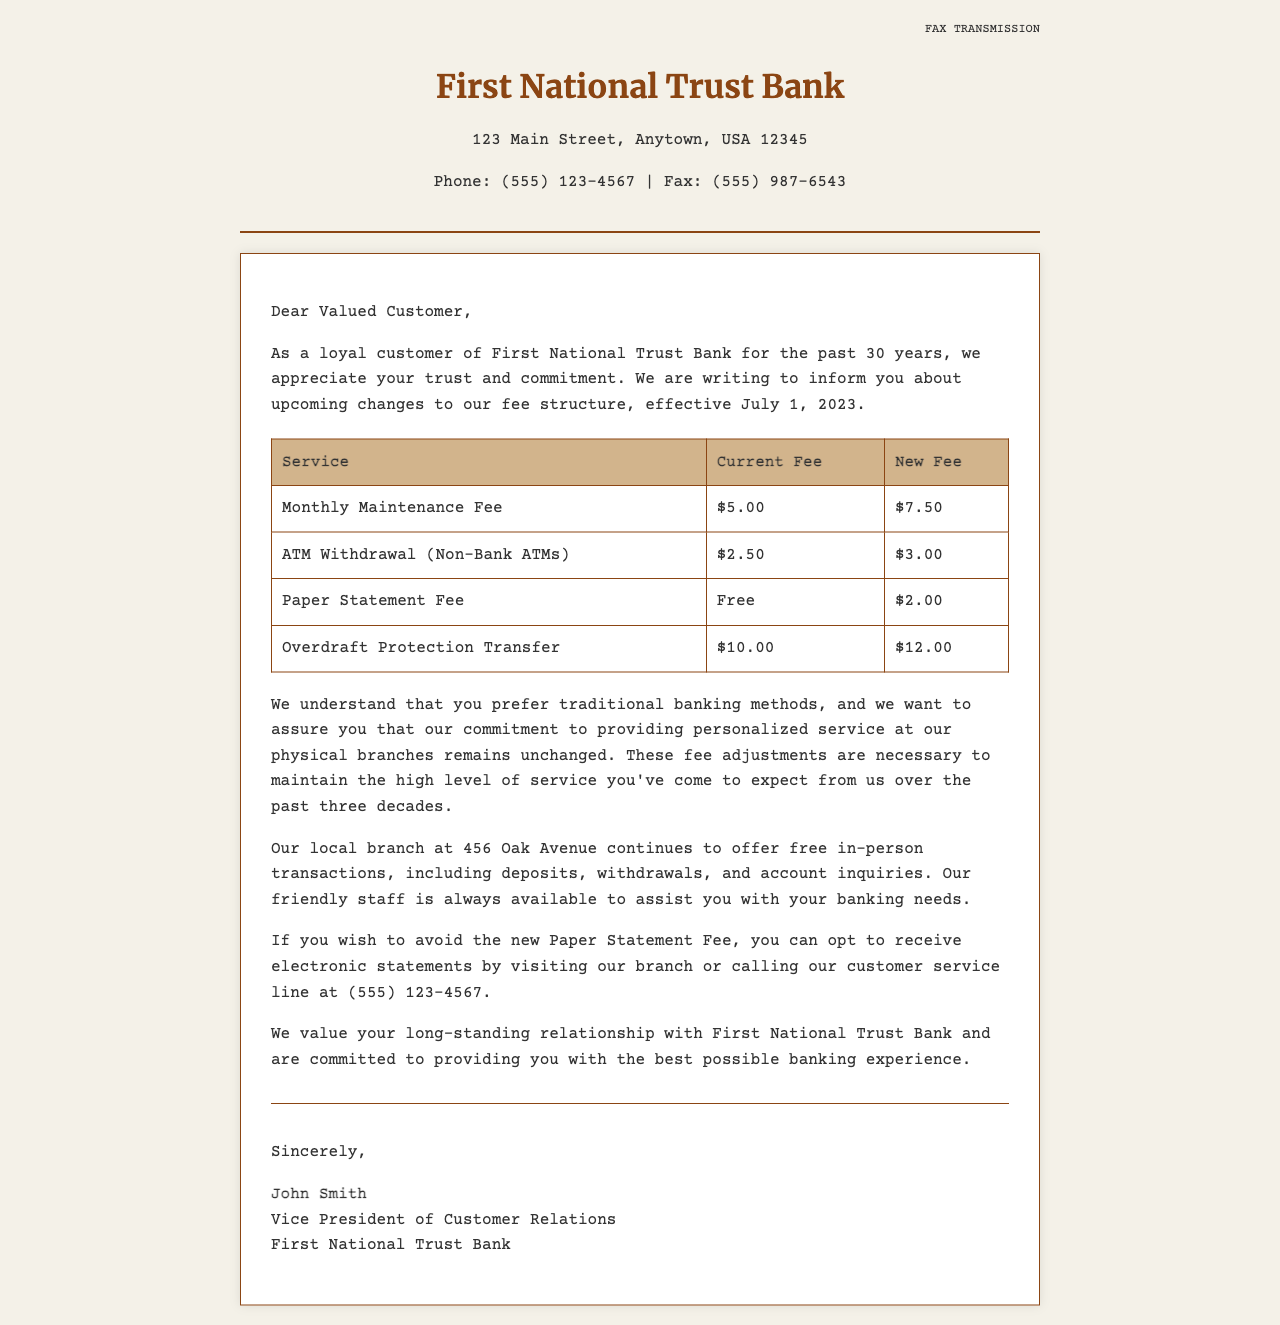What is the effective date for the new fee structure? The effective date for the new fee structure is specified in the introduction as July 1, 2023.
Answer: July 1, 2023 What is the new fee for the Monthly Maintenance Fee? The new fee for the Monthly Maintenance Fee is stated in the table as $7.50.
Answer: $7.50 What is the increase in the Paper Statement Fee? The increase can be calculated by subtracting the current fee of Free from the new fee of $2.00, resulting in a $2.00 charge.
Answer: $2.00 How much will an ATM Withdrawal from a Non-Bank ATM cost under the new fee structure? The new fee for an ATM Withdrawal from a Non-Bank ATM is listed in the document as $3.00.
Answer: $3.00 Who signed the fax? The signature section identifies the sender as John Smith, who holds the position of Vice President of Customer Relations.
Answer: John Smith What do customers need to do to avoid the new Paper Statement Fee? The document states that customers can opt to receive electronic statements to avoid this fee.
Answer: Opt for electronic statements What is the current fee for Overdraft Protection Transfer? The current fee for Overdraft Protection Transfer is detailed in the table as $10.00.
Answer: $10.00 Will the local branch still offer free in-person transactions? The content indicates that the local branch continues to offer free in-person transactions, affirming their commitment to traditional banking.
Answer: Yes What organization is associated with the fee structure changes? The introduction of the document specifies that the changes are associated with First National Trust Bank.
Answer: First National Trust Bank 